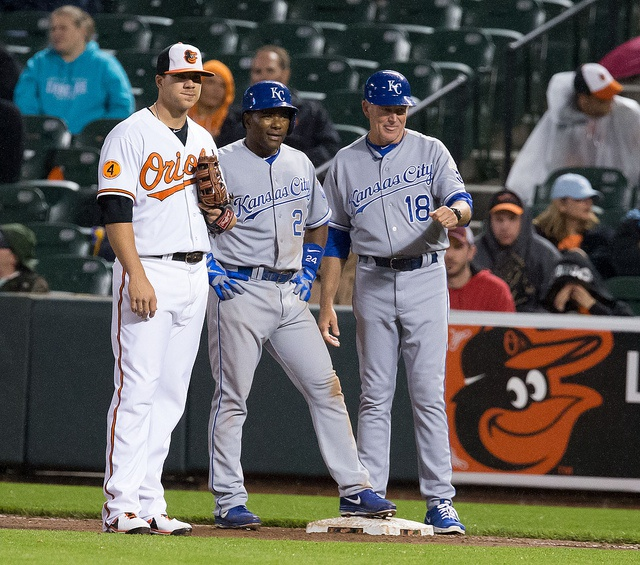Describe the objects in this image and their specific colors. I can see people in black, lavender, darkgray, and gray tones, people in black, darkgray, and gray tones, people in black, darkgray, lightgray, and gray tones, people in black, gray, and darkgray tones, and people in black, teal, blue, and gray tones in this image. 